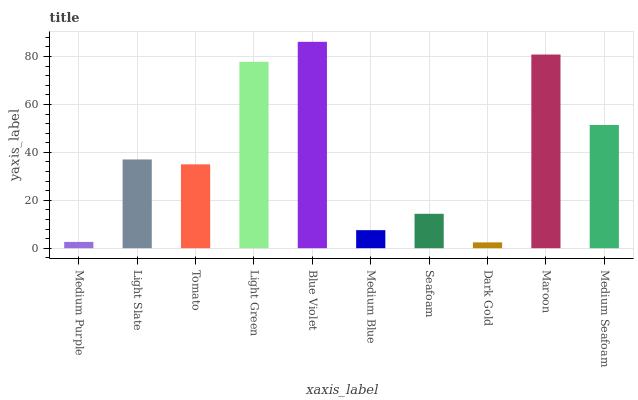Is Dark Gold the minimum?
Answer yes or no. Yes. Is Blue Violet the maximum?
Answer yes or no. Yes. Is Light Slate the minimum?
Answer yes or no. No. Is Light Slate the maximum?
Answer yes or no. No. Is Light Slate greater than Medium Purple?
Answer yes or no. Yes. Is Medium Purple less than Light Slate?
Answer yes or no. Yes. Is Medium Purple greater than Light Slate?
Answer yes or no. No. Is Light Slate less than Medium Purple?
Answer yes or no. No. Is Light Slate the high median?
Answer yes or no. Yes. Is Tomato the low median?
Answer yes or no. Yes. Is Tomato the high median?
Answer yes or no. No. Is Medium Purple the low median?
Answer yes or no. No. 